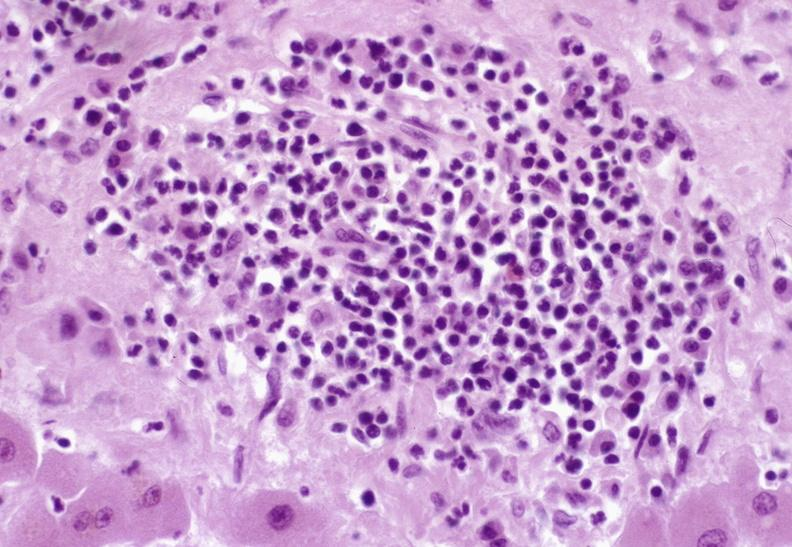does lymphangiomatosis generalized show severe acute rejection?
Answer the question using a single word or phrase. No 